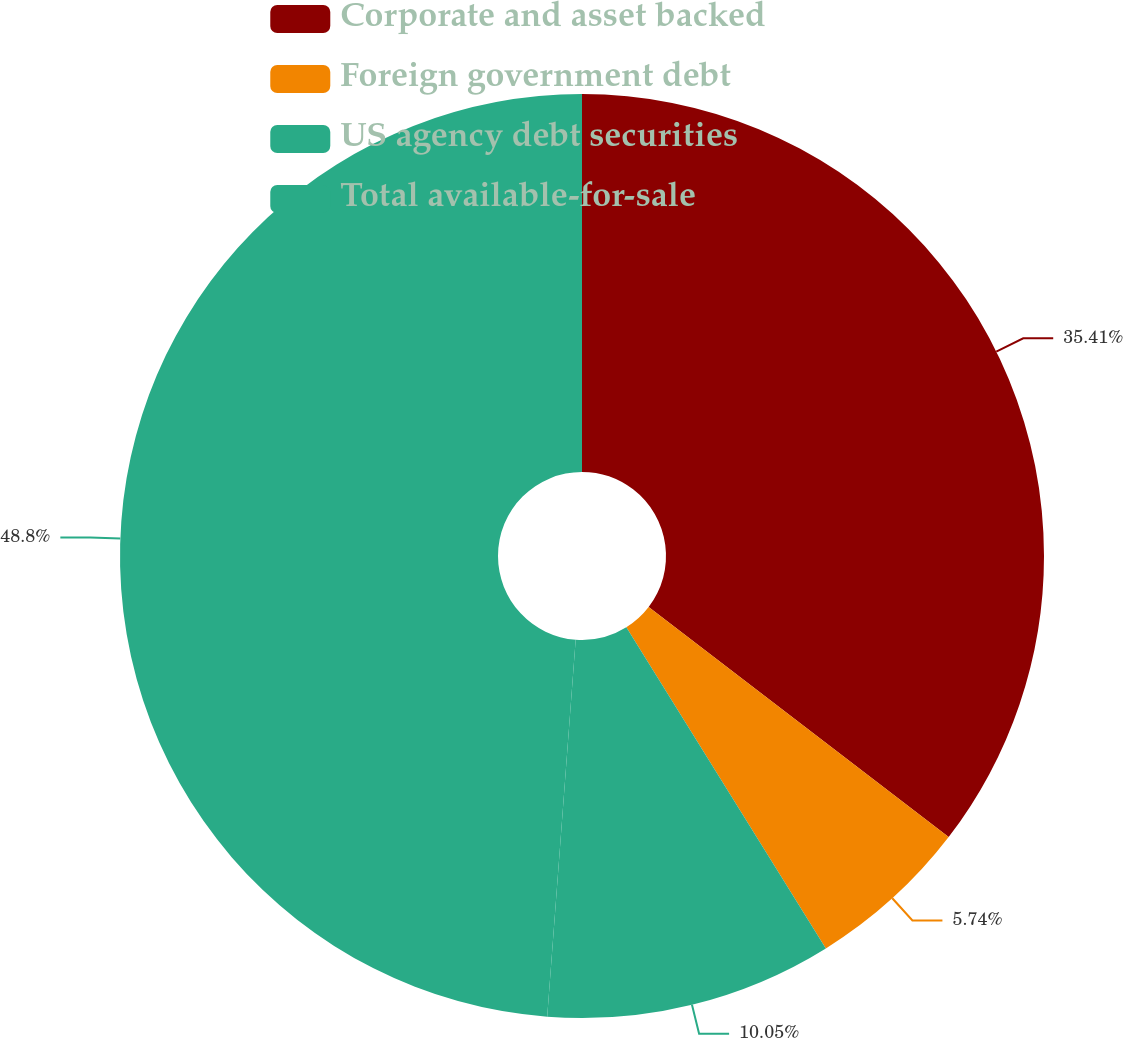<chart> <loc_0><loc_0><loc_500><loc_500><pie_chart><fcel>Corporate and asset backed<fcel>Foreign government debt<fcel>US agency debt securities<fcel>Total available-for-sale<nl><fcel>35.41%<fcel>5.74%<fcel>10.05%<fcel>48.8%<nl></chart> 